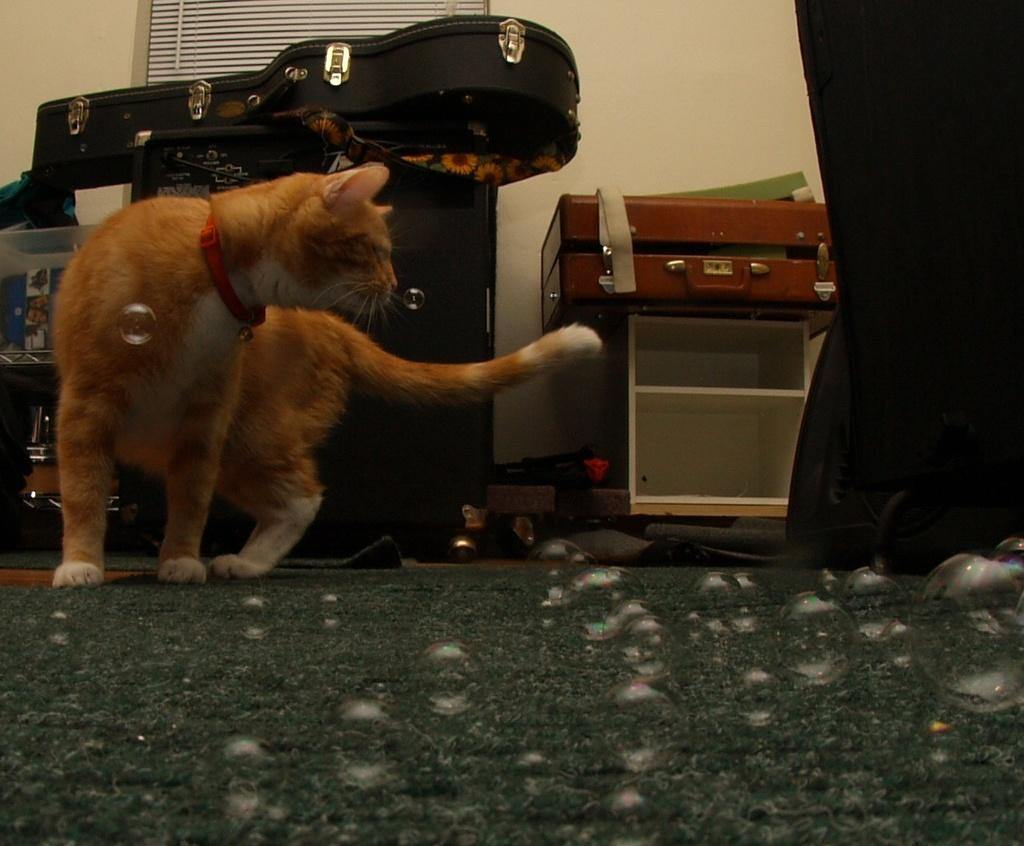What can be seen in the image that is related to water? There are water bubbles in the image. Where is the cat located in the image? The cat is on the left side of the image. What is visible in the background of the image? There are objects on a table and a wall visible in the background of the image. What type of iron is being used by the cat in the image? There is no iron present in the image, and the cat is not using any tools or objects. How many bushes are visible in the image? There are no bushes visible in the image; only water bubbles, a cat, objects on a table, and a wall are present. 